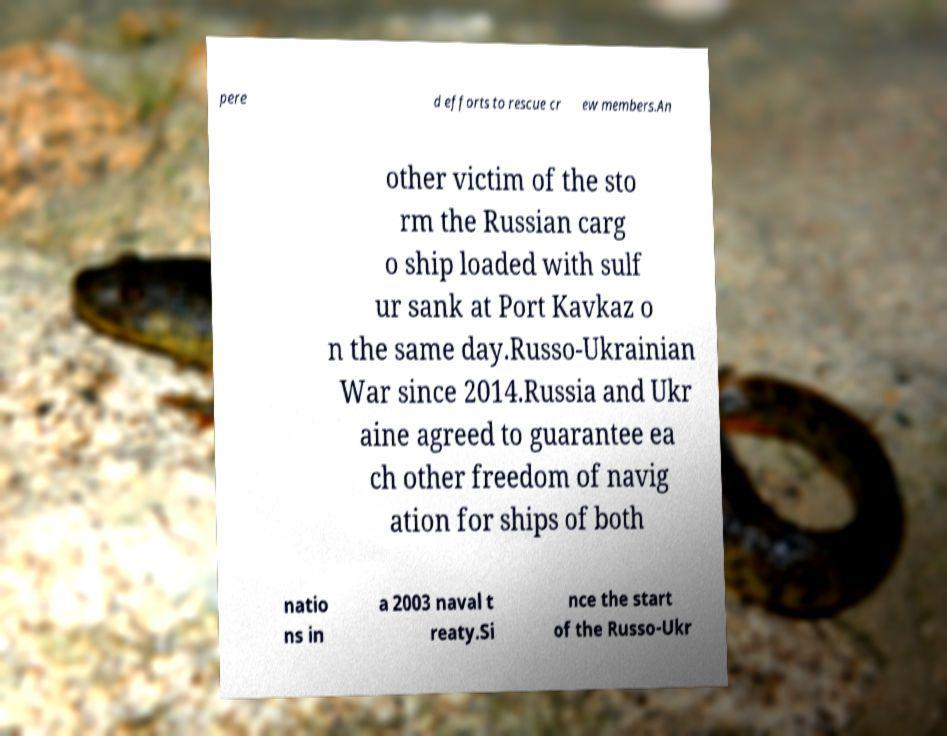There's text embedded in this image that I need extracted. Can you transcribe it verbatim? pere d efforts to rescue cr ew members.An other victim of the sto rm the Russian carg o ship loaded with sulf ur sank at Port Kavkaz o n the same day.Russo-Ukrainian War since 2014.Russia and Ukr aine agreed to guarantee ea ch other freedom of navig ation for ships of both natio ns in a 2003 naval t reaty.Si nce the start of the Russo-Ukr 